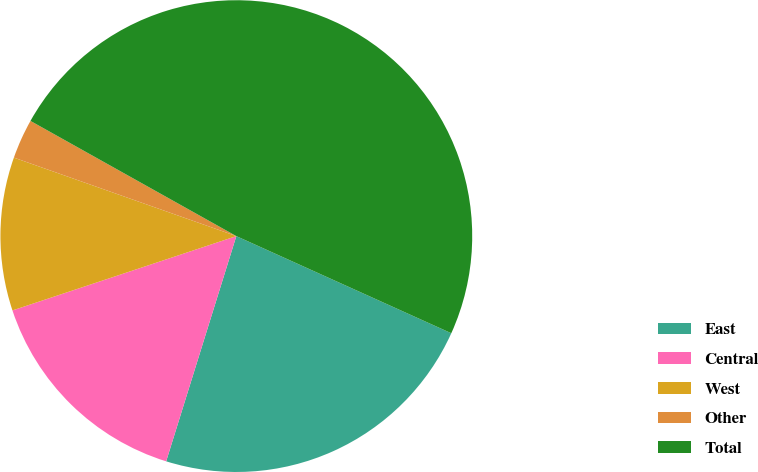Convert chart. <chart><loc_0><loc_0><loc_500><loc_500><pie_chart><fcel>East<fcel>Central<fcel>West<fcel>Other<fcel>Total<nl><fcel>23.05%<fcel>15.09%<fcel>10.5%<fcel>2.72%<fcel>48.63%<nl></chart> 